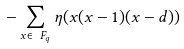Convert formula to latex. <formula><loc_0><loc_0><loc_500><loc_500>- \sum _ { x \in \ F _ { q } } \eta ( x ( x - 1 ) ( x - d ) )</formula> 